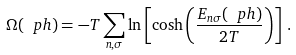<formula> <loc_0><loc_0><loc_500><loc_500>\Omega ( \ p h ) = - T \sum _ { n , \sigma } \ln \left [ \cosh \left ( \frac { E _ { n \sigma } ( \ p h ) } { 2 T } \right ) \right ] \, .</formula> 